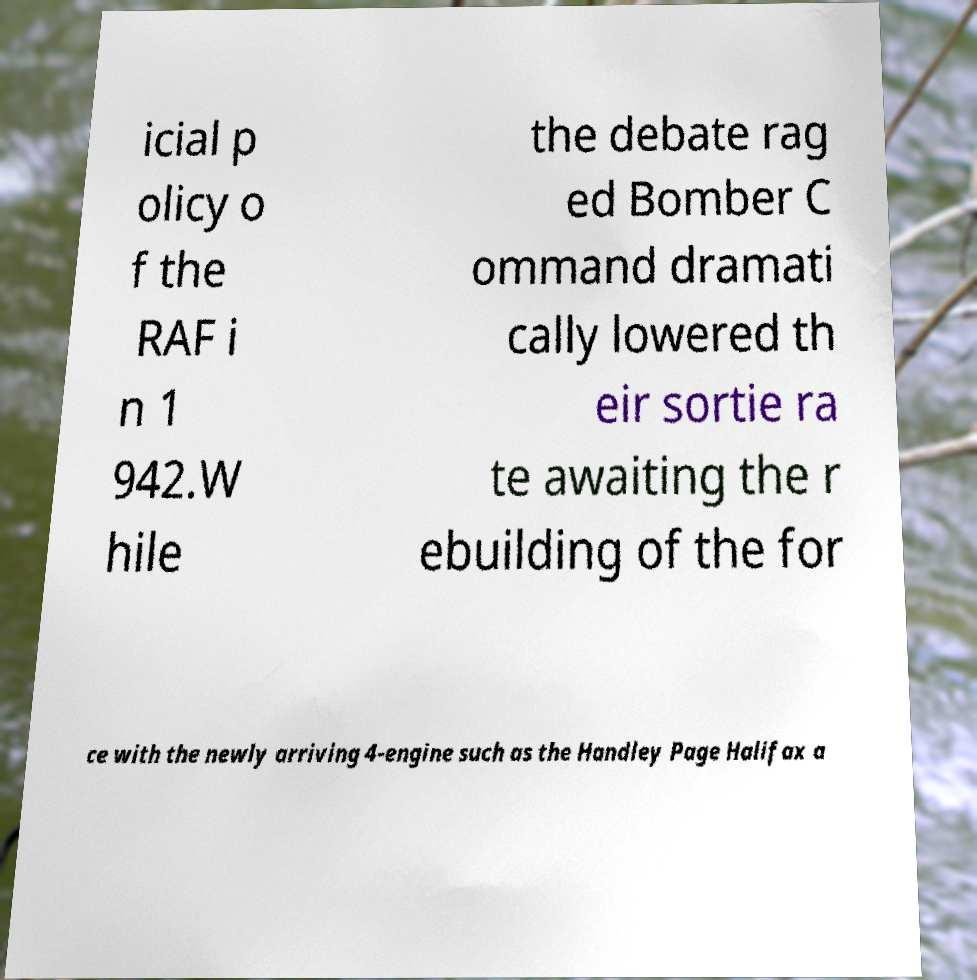I need the written content from this picture converted into text. Can you do that? icial p olicy o f the RAF i n 1 942.W hile the debate rag ed Bomber C ommand dramati cally lowered th eir sortie ra te awaiting the r ebuilding of the for ce with the newly arriving 4-engine such as the Handley Page Halifax a 